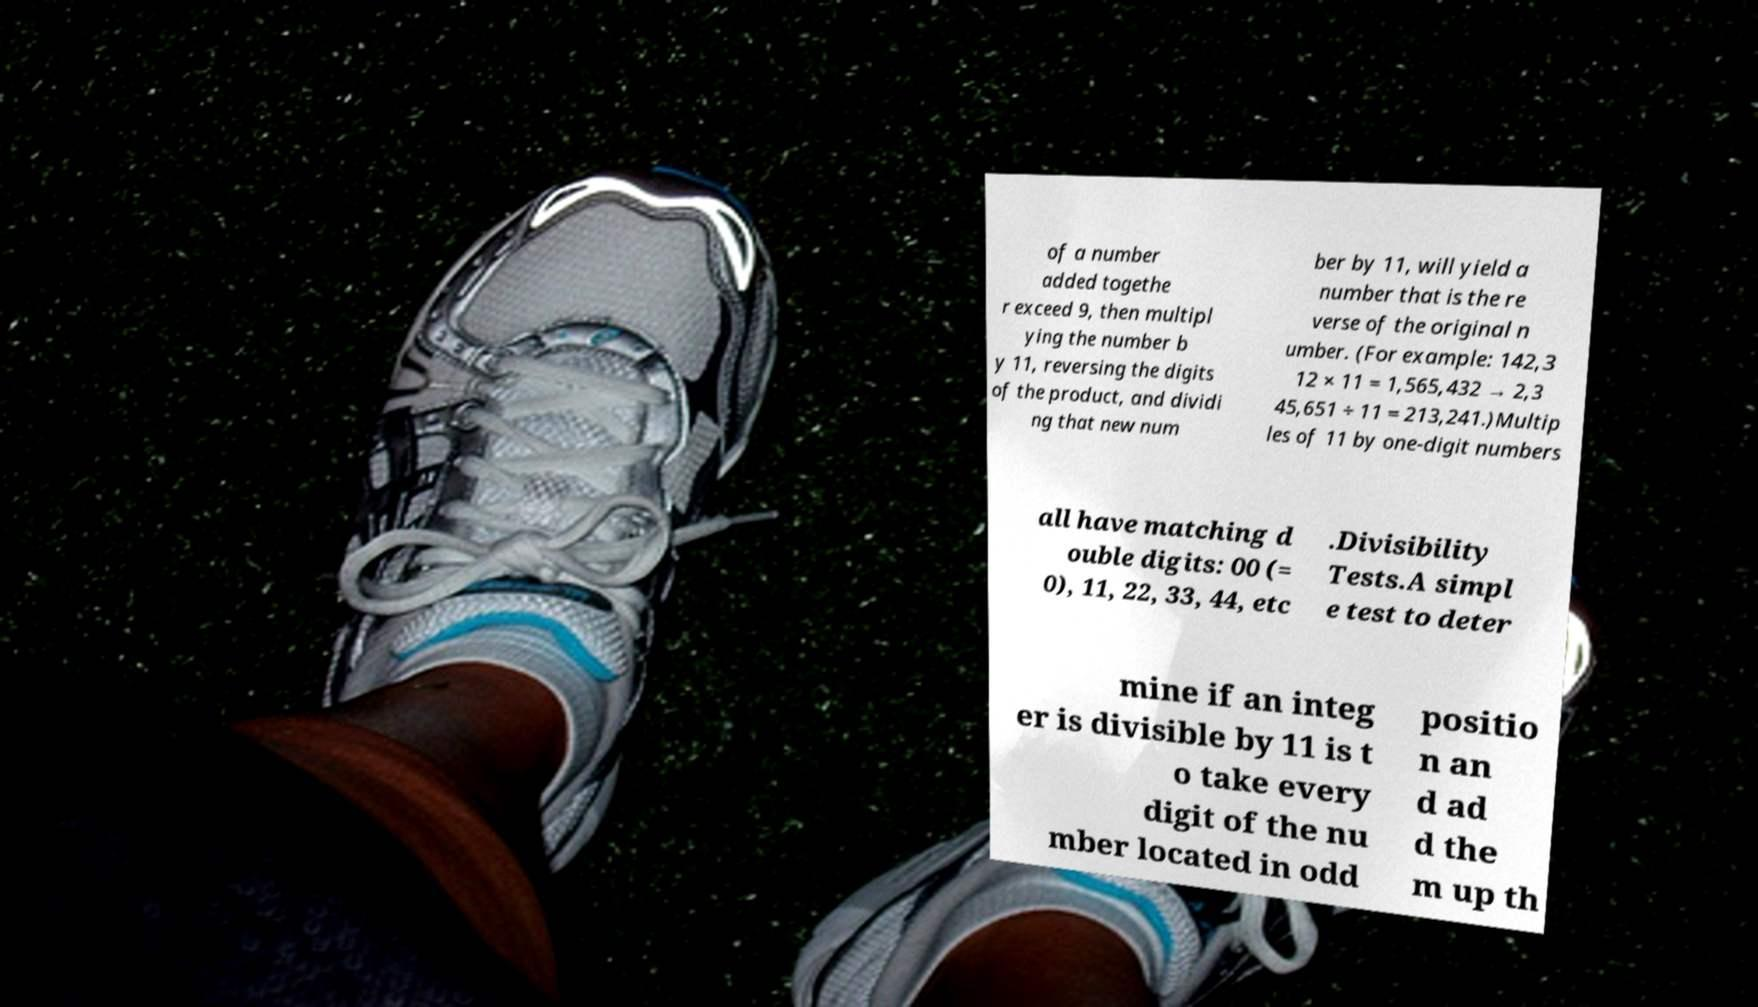Please identify and transcribe the text found in this image. of a number added togethe r exceed 9, then multipl ying the number b y 11, reversing the digits of the product, and dividi ng that new num ber by 11, will yield a number that is the re verse of the original n umber. (For example: 142,3 12 × 11 = 1,565,432 → 2,3 45,651 ÷ 11 = 213,241.)Multip les of 11 by one-digit numbers all have matching d ouble digits: 00 (= 0), 11, 22, 33, 44, etc .Divisibility Tests.A simpl e test to deter mine if an integ er is divisible by 11 is t o take every digit of the nu mber located in odd positio n an d ad d the m up th 